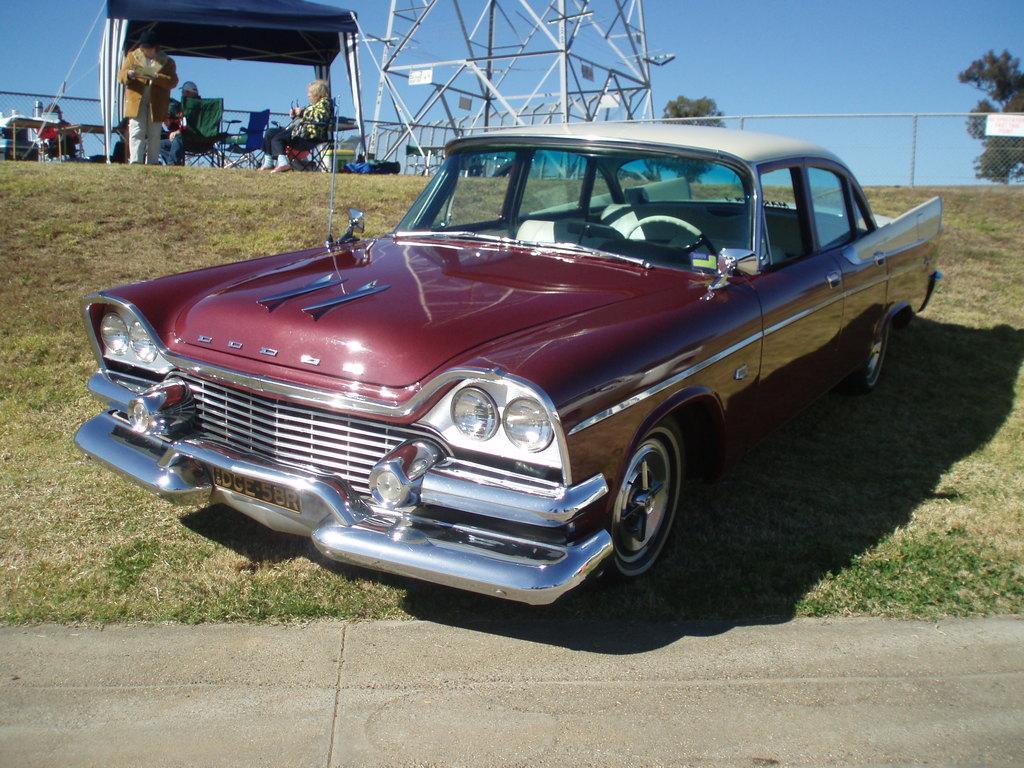Describe this image in one or two sentences. In this picture there is a red color car which is parked near to the road. On the left we can see the grass. At the top we can see the tower. In the top left corner there is a woman who is sitting on the chair. Beside her there is a man who is standing near to the table. Backside of him we can see the tent. On the table we can see the coke cans, water bottles and other objects. Beside the table we can see the fencing. In the top right corner we can see the trees. Here it's a sky. 